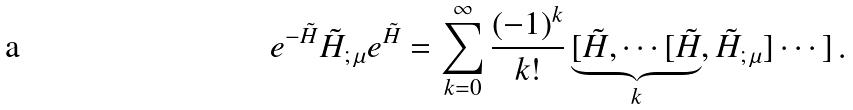Convert formula to latex. <formula><loc_0><loc_0><loc_500><loc_500>e ^ { - \tilde { H } } \tilde { H } _ { ; \, \mu } e ^ { \tilde { H } } = \sum _ { k = 0 } ^ { \infty } \frac { ( - 1 ) ^ { k } } { k ! } \underbrace { [ \tilde { H } , \cdots [ \tilde { H } } _ { k } , \tilde { H } _ { ; \, \mu } ] \cdots ] \, .</formula> 